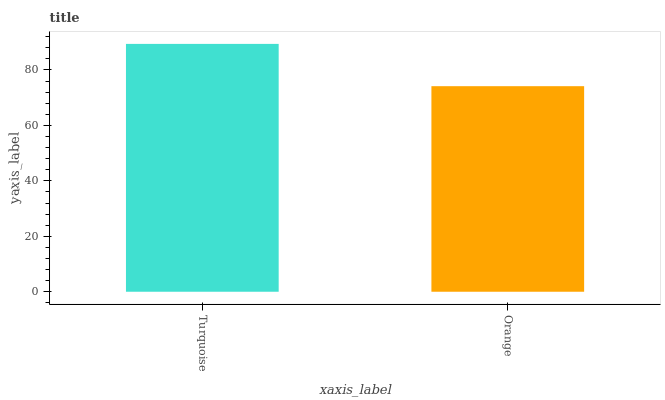Is Orange the minimum?
Answer yes or no. Yes. Is Turquoise the maximum?
Answer yes or no. Yes. Is Orange the maximum?
Answer yes or no. No. Is Turquoise greater than Orange?
Answer yes or no. Yes. Is Orange less than Turquoise?
Answer yes or no. Yes. Is Orange greater than Turquoise?
Answer yes or no. No. Is Turquoise less than Orange?
Answer yes or no. No. Is Turquoise the high median?
Answer yes or no. Yes. Is Orange the low median?
Answer yes or no. Yes. Is Orange the high median?
Answer yes or no. No. Is Turquoise the low median?
Answer yes or no. No. 